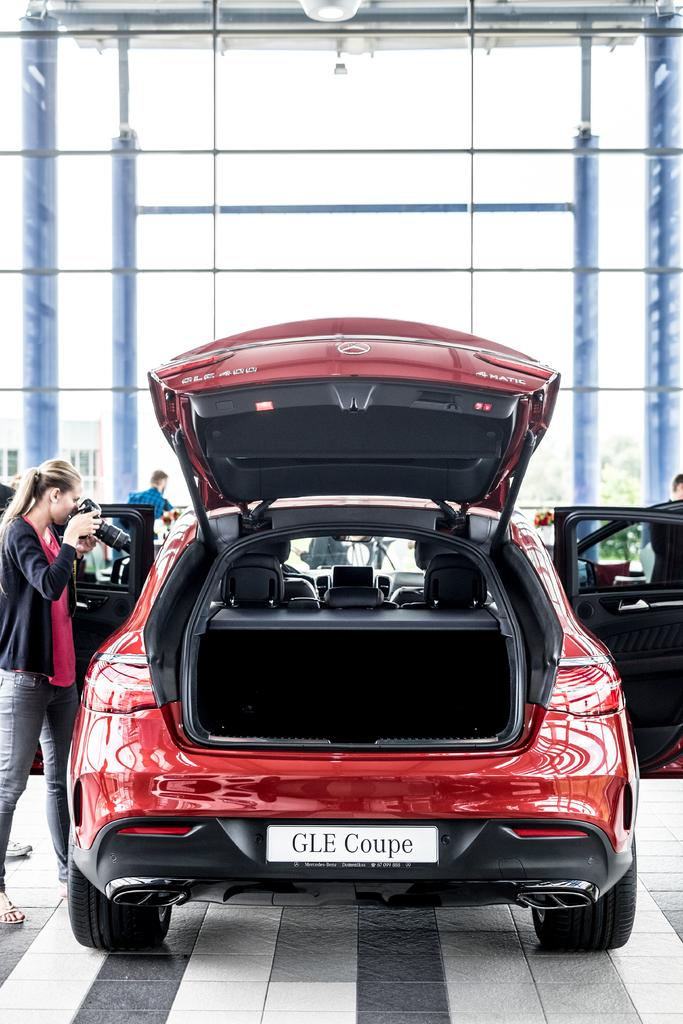What is on the path in the image? There is a car on the path in the image. Who is present near the car in the image? There is a woman holding a camera on the left side of the car. What is in front of the car in the image? There are glasses and trees in front of the car. What type of knowledge can be gained from the car's digestion in the image? There is no car digestion present in the image, as cars do not have digestive systems. 